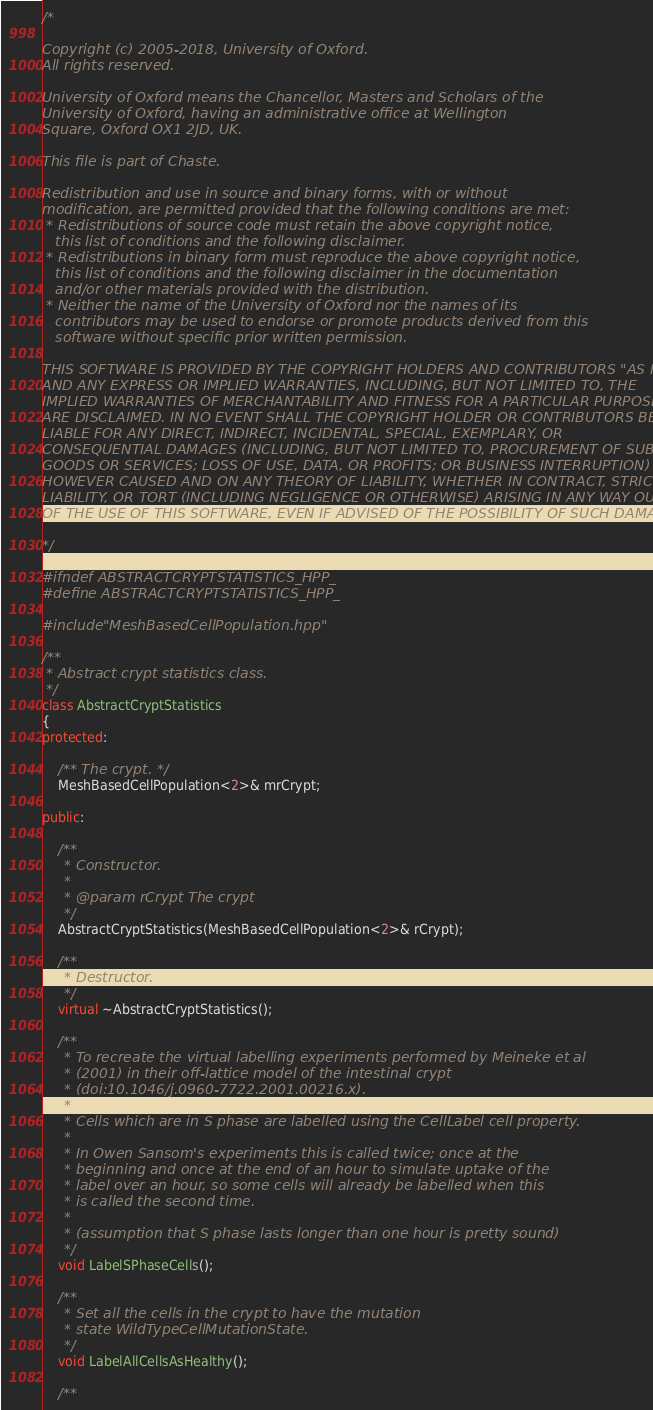<code> <loc_0><loc_0><loc_500><loc_500><_C++_>/*

Copyright (c) 2005-2018, University of Oxford.
All rights reserved.

University of Oxford means the Chancellor, Masters and Scholars of the
University of Oxford, having an administrative office at Wellington
Square, Oxford OX1 2JD, UK.

This file is part of Chaste.

Redistribution and use in source and binary forms, with or without
modification, are permitted provided that the following conditions are met:
 * Redistributions of source code must retain the above copyright notice,
   this list of conditions and the following disclaimer.
 * Redistributions in binary form must reproduce the above copyright notice,
   this list of conditions and the following disclaimer in the documentation
   and/or other materials provided with the distribution.
 * Neither the name of the University of Oxford nor the names of its
   contributors may be used to endorse or promote products derived from this
   software without specific prior written permission.

THIS SOFTWARE IS PROVIDED BY THE COPYRIGHT HOLDERS AND CONTRIBUTORS "AS IS"
AND ANY EXPRESS OR IMPLIED WARRANTIES, INCLUDING, BUT NOT LIMITED TO, THE
IMPLIED WARRANTIES OF MERCHANTABILITY AND FITNESS FOR A PARTICULAR PURPOSE
ARE DISCLAIMED. IN NO EVENT SHALL THE COPYRIGHT HOLDER OR CONTRIBUTORS BE
LIABLE FOR ANY DIRECT, INDIRECT, INCIDENTAL, SPECIAL, EXEMPLARY, OR
CONSEQUENTIAL DAMAGES (INCLUDING, BUT NOT LIMITED TO, PROCUREMENT OF SUBSTITUTE
GOODS OR SERVICES; LOSS OF USE, DATA, OR PROFITS; OR BUSINESS INTERRUPTION)
HOWEVER CAUSED AND ON ANY THEORY OF LIABILITY, WHETHER IN CONTRACT, STRICT
LIABILITY, OR TORT (INCLUDING NEGLIGENCE OR OTHERWISE) ARISING IN ANY WAY OUT
OF THE USE OF THIS SOFTWARE, EVEN IF ADVISED OF THE POSSIBILITY OF SUCH DAMAGE.

*/

#ifndef ABSTRACTCRYPTSTATISTICS_HPP_
#define ABSTRACTCRYPTSTATISTICS_HPP_

#include "MeshBasedCellPopulation.hpp"

/**
 * Abstract crypt statistics class.
 */
class AbstractCryptStatistics
{
protected:

    /** The crypt. */
    MeshBasedCellPopulation<2>& mrCrypt;

public:

    /**
     * Constructor.
     *
     * @param rCrypt The crypt
     */
    AbstractCryptStatistics(MeshBasedCellPopulation<2>& rCrypt);

    /**
     * Destructor.
     */
    virtual ~AbstractCryptStatistics();

    /**
     * To recreate the virtual labelling experiments performed by Meineke et al
     * (2001) in their off-lattice model of the intestinal crypt
     * (doi:10.1046/j.0960-7722.2001.00216.x).
     *
     * Cells which are in S phase are labelled using the CellLabel cell property.
     *
     * In Owen Sansom's experiments this is called twice; once at the
     * beginning and once at the end of an hour to simulate uptake of the
     * label over an hour, so some cells will already be labelled when this
     * is called the second time.
     *
     * (assumption that S phase lasts longer than one hour is pretty sound)
     */
    void LabelSPhaseCells();

    /**
     * Set all the cells in the crypt to have the mutation
     * state WildTypeCellMutationState.
     */
    void LabelAllCellsAsHealthy();

    /**</code> 